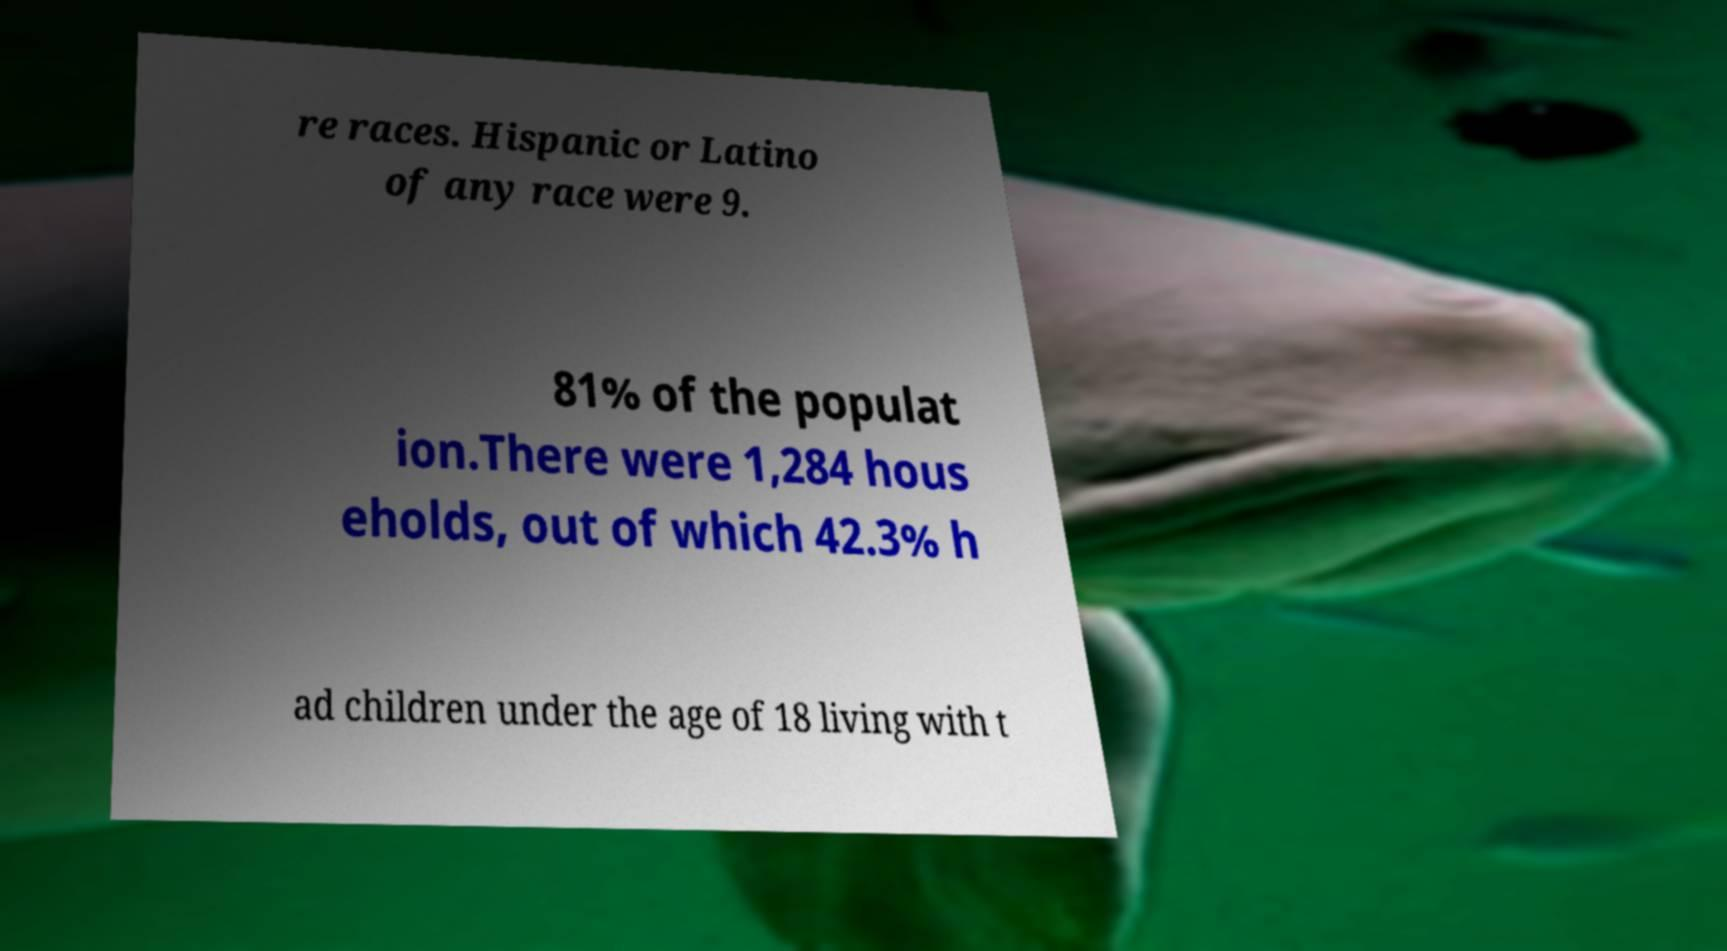For documentation purposes, I need the text within this image transcribed. Could you provide that? re races. Hispanic or Latino of any race were 9. 81% of the populat ion.There were 1,284 hous eholds, out of which 42.3% h ad children under the age of 18 living with t 